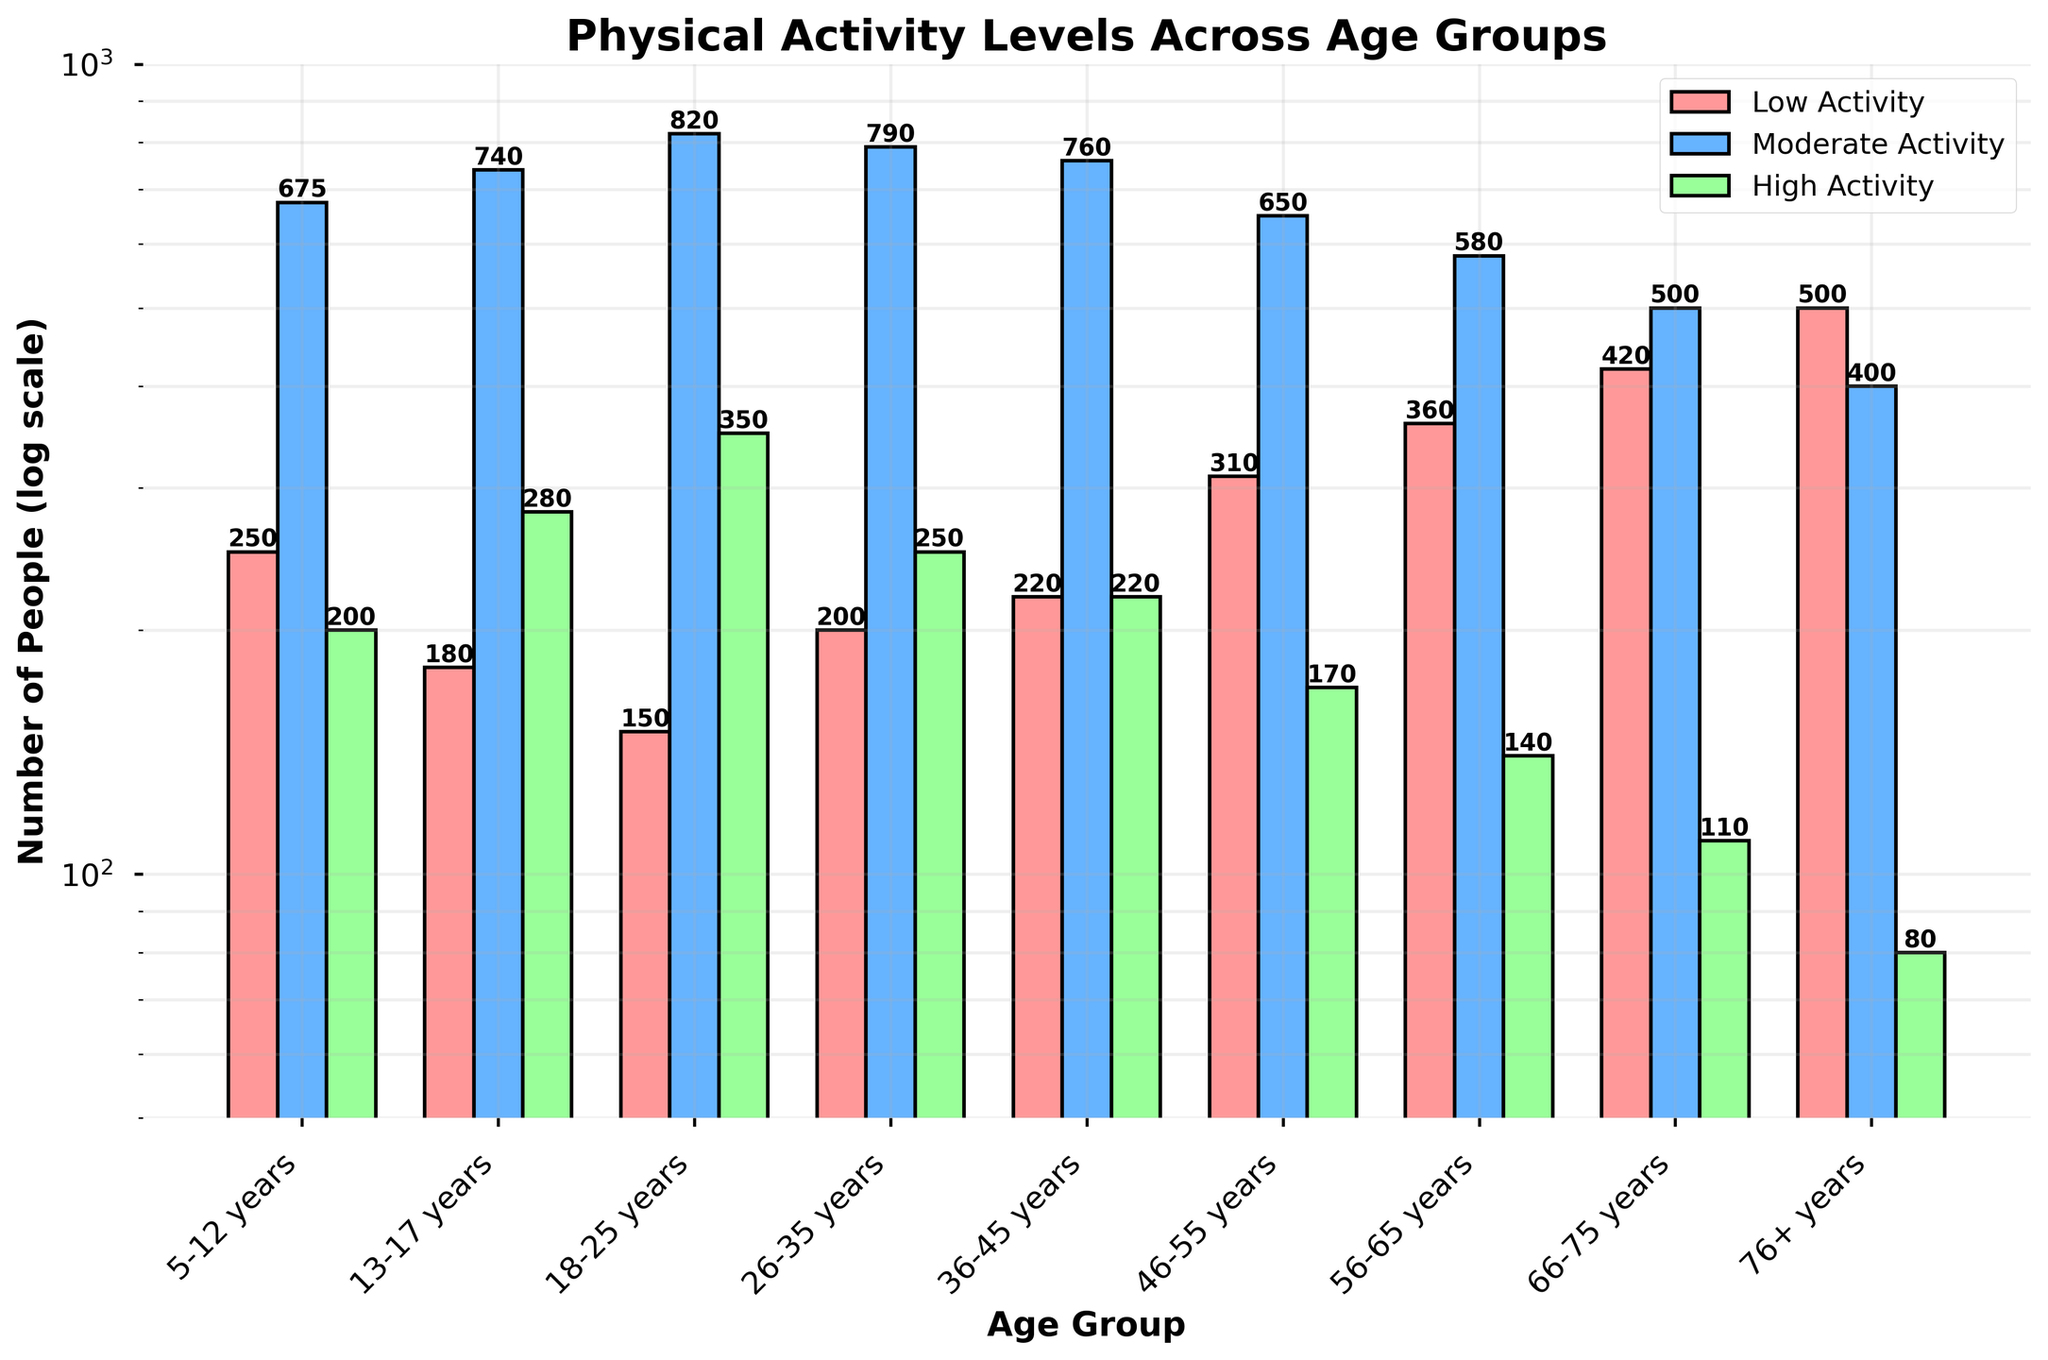What's the title of the figure? The title of the figure is prominently displayed at the top center of the plot.
Answer: Physical Activity Levels Across Age Groups What does the y-axis represent? The y-axis label is clearly indicated as "Number of People (log scale),” suggesting the count of people engaged in different activity levels, displayed on a logarithmic scale.
Answer: Number of People (log scale) Which age group has the highest number of people with low activity levels? The tallest bar in the "Low Activity" segment corresponds to the 76+ years age group. This information can be directly read from the height of the relevant bar section on the figure.
Answer: 76+ years In the 36-45 years age group, how many people are moderately active? The value displayed atop the blue bar in the "36-45 years" section represents the count of moderately active individuals. Reading this value gives us 760.
Answer: 760 Which age group has the highest number of high activity people? The tallest green bar in the "High Activity" segment corresponds to the 18-25 years age group, indicating the age group with the highest number of people in high activity.
Answer: 18-25 years Compare the number of people with low activity levels in the 56-65 years and 66-75 years age groups. Which one is greater, and by how much? The height of the red bars indicates that the 66-75 years group has 420 people in low activity, whereas the 56-65 years group has 360. Therefore, 420 - 360 gives us the difference.
Answer: 66-75 years, by 60 people What is the overall trend in the number of people with low activity as the age increases? Observing the red bars across different age groups reveals an increasing trend in the number of people with low activity as age increases.
Answer: Increasing trend What is the range of the number of people in high activity levels across all age groups? By looking at the heights of the green bars, the minimum value is 80 (76+ years) and the maximum value is 350 (18-25 years). Hence, the range is 350 - 80.
Answer: 270 people How do people with moderate activity in the 13-17 years group compare to those in the 26-35 years group? Both the blue bars corresponding to the 13-17 years and 26-35 years age groups must be compared. The 13-17 years have 740 people, while 26-35 years have 790 people.
Answer: 26-35 years > 13-17 years by 50 people Why might it be useful to use a log scale for the y-axis in this figure? Using a log scale on the y-axis helps in better visualizing the data when the range of values is large, allowing smaller values to be compared more easily with larger ones and avoiding the smaller numbers being compressed at the bottom of the scale.
Answer: To better visualize a wide range of values 